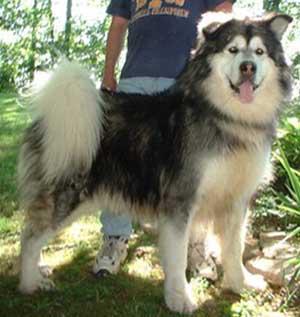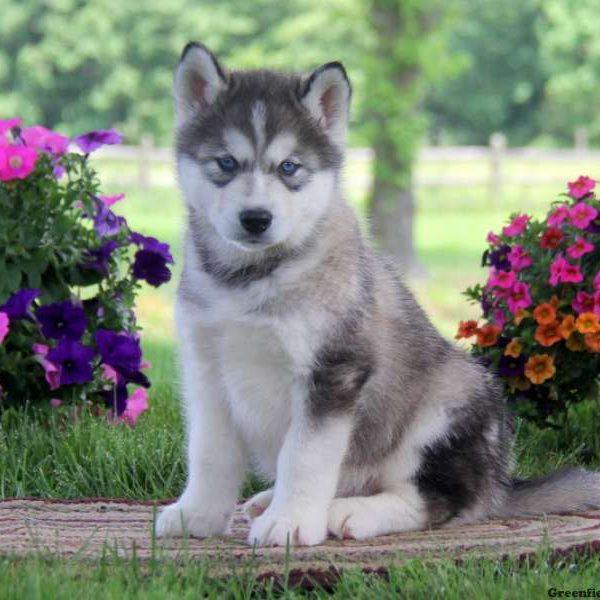The first image is the image on the left, the second image is the image on the right. Considering the images on both sides, is "The left and right image contains the same number of dogs with one sitting while the other stands with his tongue out." valid? Answer yes or no. Yes. The first image is the image on the left, the second image is the image on the right. Evaluate the accuracy of this statement regarding the images: "A man is standing behind a big husky dog, who is standing with his face forward and his tongue hanging.". Is it true? Answer yes or no. Yes. 